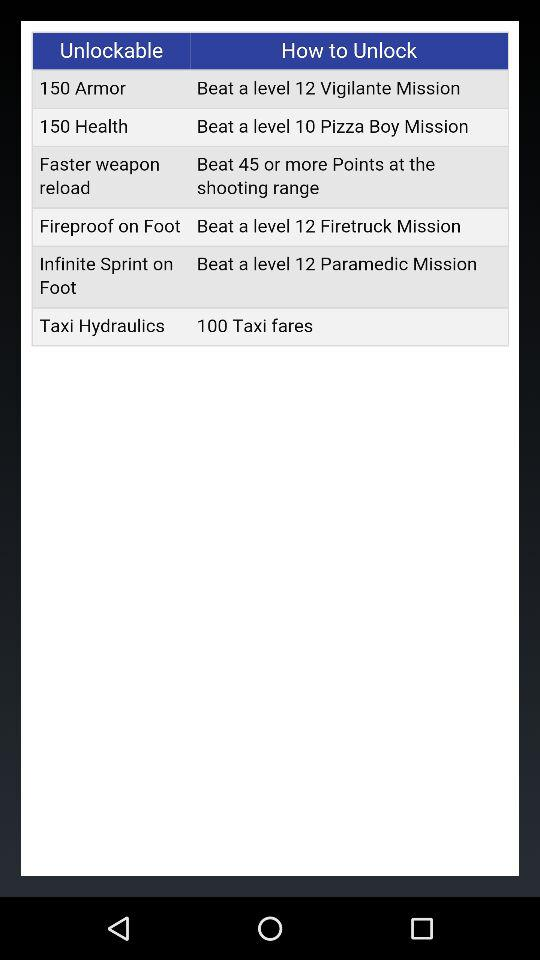How many unlockables are there?
Answer the question using a single word or phrase. 6 